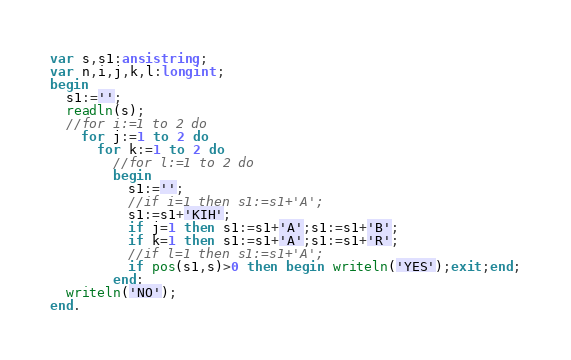<code> <loc_0><loc_0><loc_500><loc_500><_Pascal_>var s,s1:ansistring;
var n,i,j,k,l:longint;
begin
  s1:='';
  readln(s);
  //for i:=1 to 2 do
    for j:=1 to 2 do
      for k:=1 to 2 do
        //for l:=1 to 2 do
        begin
          s1:='';
          //if i=1 then s1:=s1+'A';
          s1:=s1+'KIH';
          if j=1 then s1:=s1+'A';s1:=s1+'B';
          if k=1 then s1:=s1+'A';s1:=s1+'R';
          //if l=1 then s1:=s1+'A';
          if pos(s1,s)>0 then begin writeln('YES');exit;end;
        end;
  writeln('NO');
end.</code> 